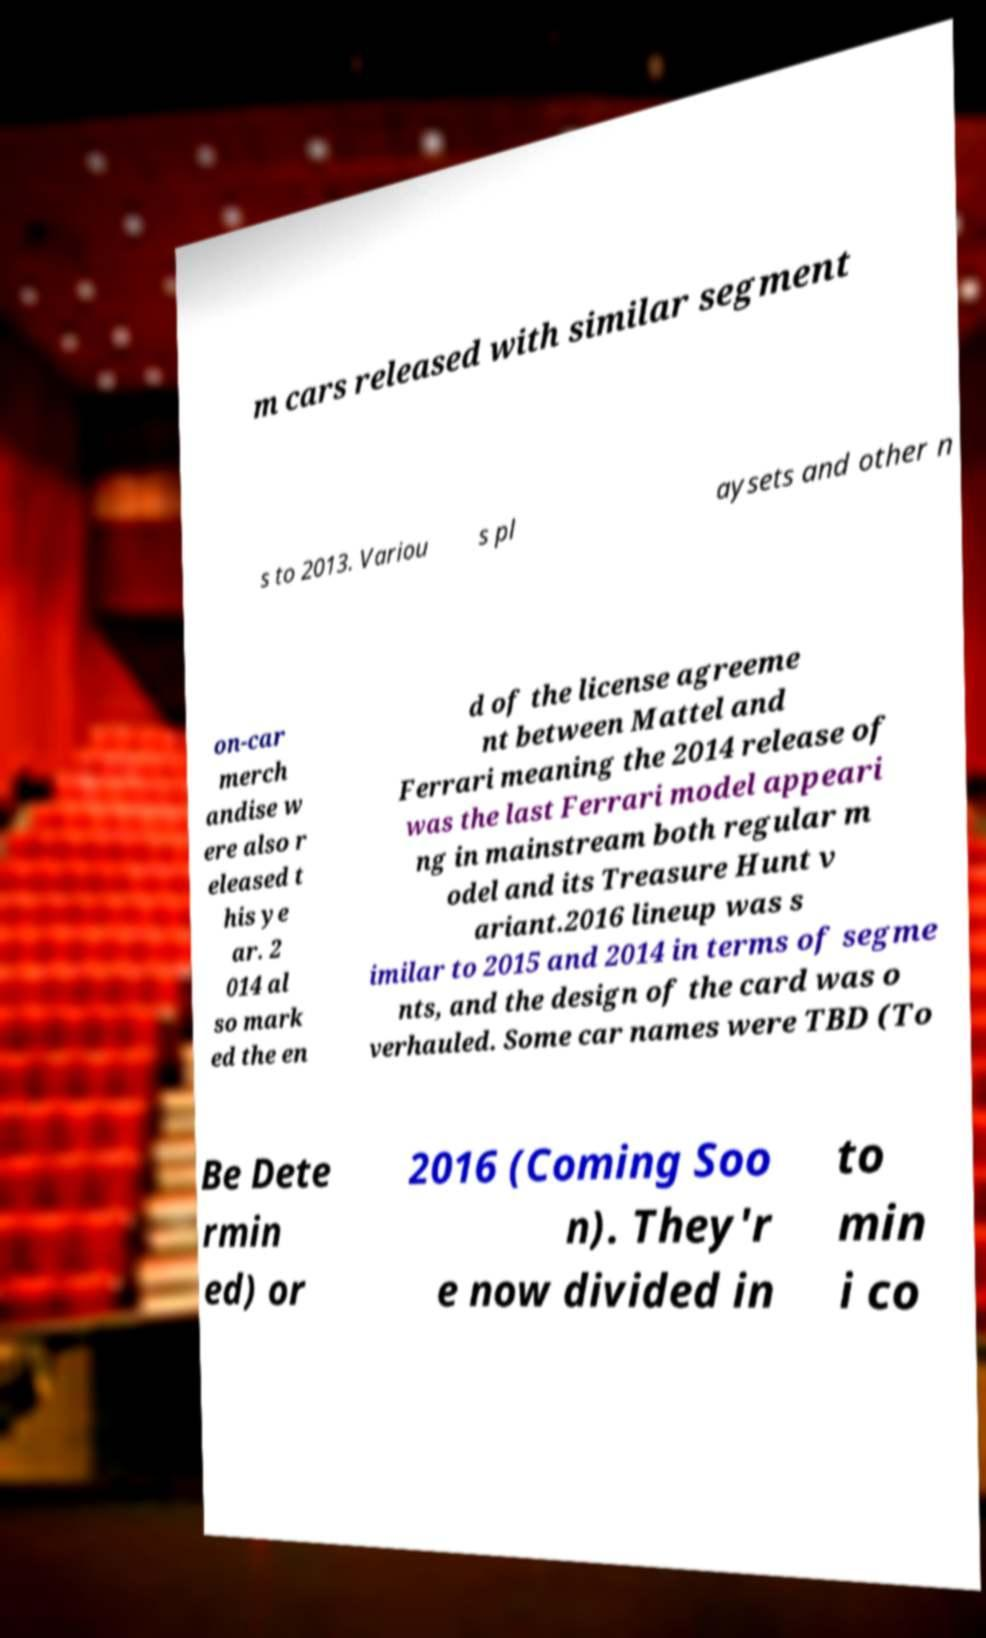Please identify and transcribe the text found in this image. m cars released with similar segment s to 2013. Variou s pl aysets and other n on-car merch andise w ere also r eleased t his ye ar. 2 014 al so mark ed the en d of the license agreeme nt between Mattel and Ferrari meaning the 2014 release of was the last Ferrari model appeari ng in mainstream both regular m odel and its Treasure Hunt v ariant.2016 lineup was s imilar to 2015 and 2014 in terms of segme nts, and the design of the card was o verhauled. Some car names were TBD (To Be Dete rmin ed) or 2016 (Coming Soo n). They'r e now divided in to min i co 